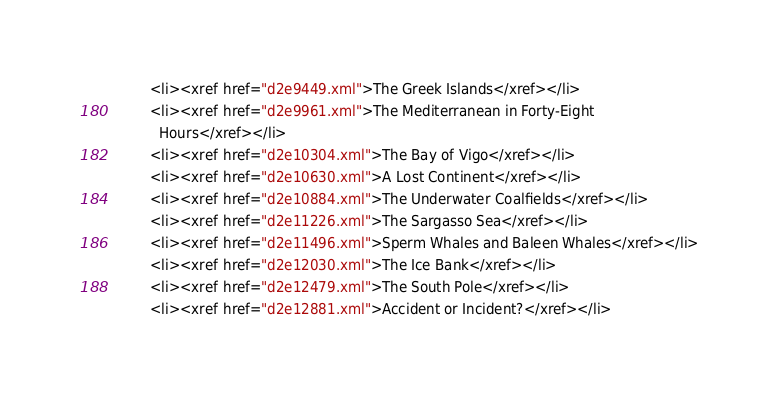Convert code to text. <code><loc_0><loc_0><loc_500><loc_500><_XML_>        <li><xref href="d2e9449.xml">The Greek Islands</xref></li>
        <li><xref href="d2e9961.xml">The Mediterranean in Forty-Eight
          Hours</xref></li>
        <li><xref href="d2e10304.xml">The Bay of Vigo</xref></li>
        <li><xref href="d2e10630.xml">A Lost Continent</xref></li>
        <li><xref href="d2e10884.xml">The Underwater Coalfields</xref></li>
        <li><xref href="d2e11226.xml">The Sargasso Sea</xref></li>
        <li><xref href="d2e11496.xml">Sperm Whales and Baleen Whales</xref></li>
        <li><xref href="d2e12030.xml">The Ice Bank</xref></li>
        <li><xref href="d2e12479.xml">The South Pole</xref></li>
        <li><xref href="d2e12881.xml">Accident or Incident?</xref></li></code> 